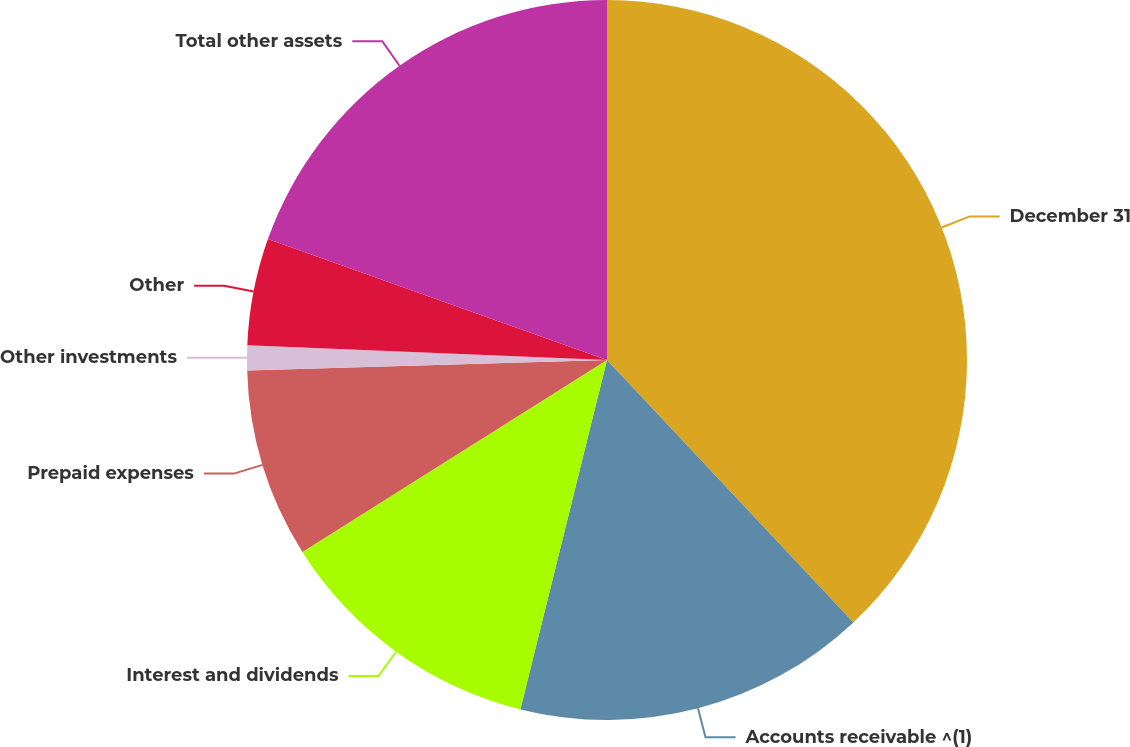<chart> <loc_0><loc_0><loc_500><loc_500><pie_chart><fcel>December 31<fcel>Accounts receivable ^(1)<fcel>Interest and dividends<fcel>Prepaid expenses<fcel>Other investments<fcel>Other<fcel>Total other assets<nl><fcel>38.0%<fcel>15.87%<fcel>12.18%<fcel>8.49%<fcel>1.11%<fcel>4.8%<fcel>19.55%<nl></chart> 